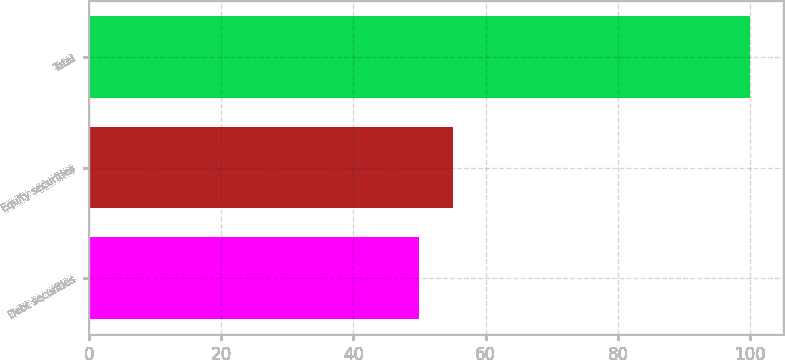Convert chart to OTSL. <chart><loc_0><loc_0><loc_500><loc_500><bar_chart><fcel>Debt securities<fcel>Equity securities<fcel>Total<nl><fcel>50<fcel>55<fcel>100<nl></chart> 